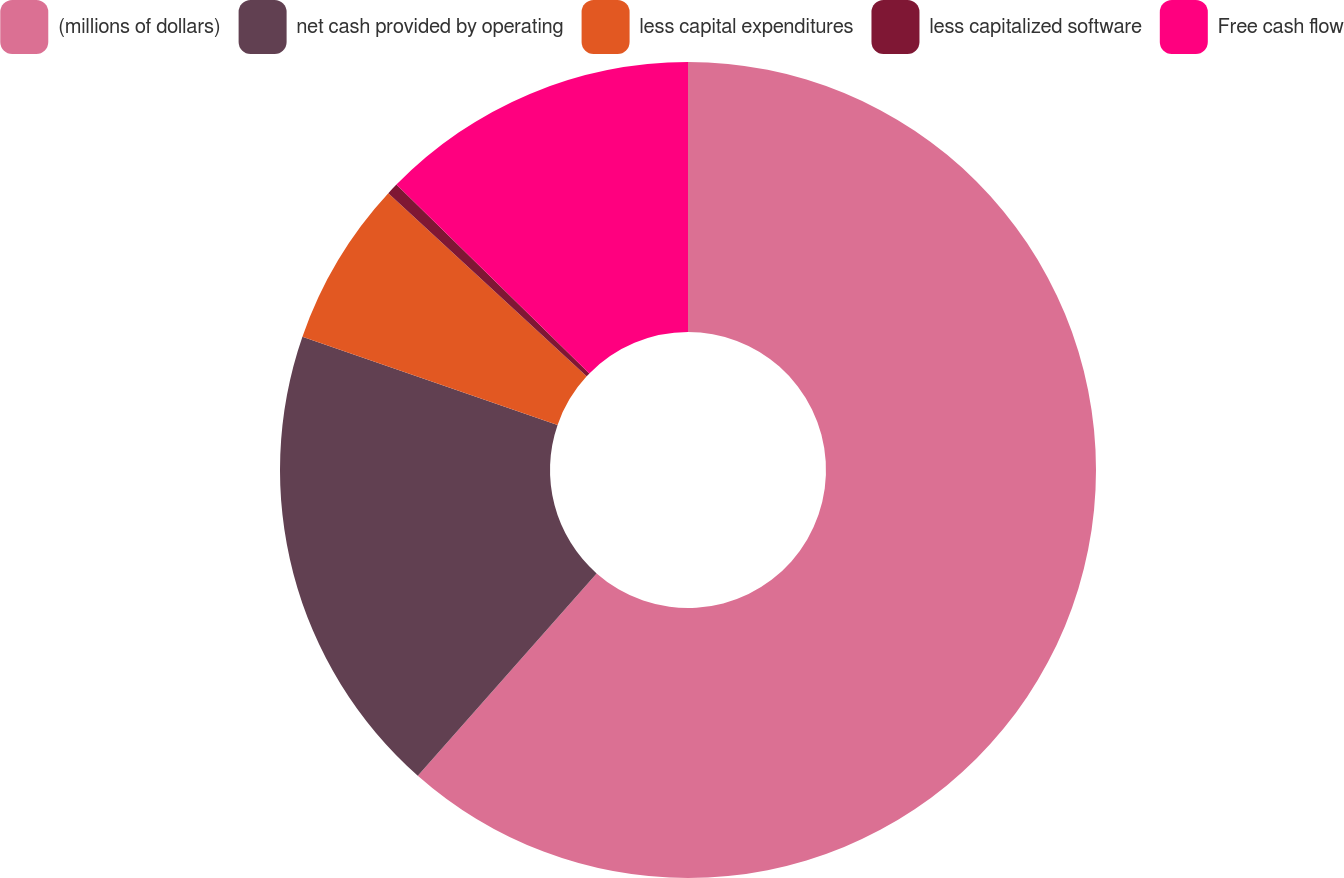Convert chart. <chart><loc_0><loc_0><loc_500><loc_500><pie_chart><fcel>(millions of dollars)<fcel>net cash provided by operating<fcel>less capital expenditures<fcel>less capitalized software<fcel>Free cash flow<nl><fcel>61.52%<fcel>18.78%<fcel>6.57%<fcel>0.46%<fcel>12.67%<nl></chart> 